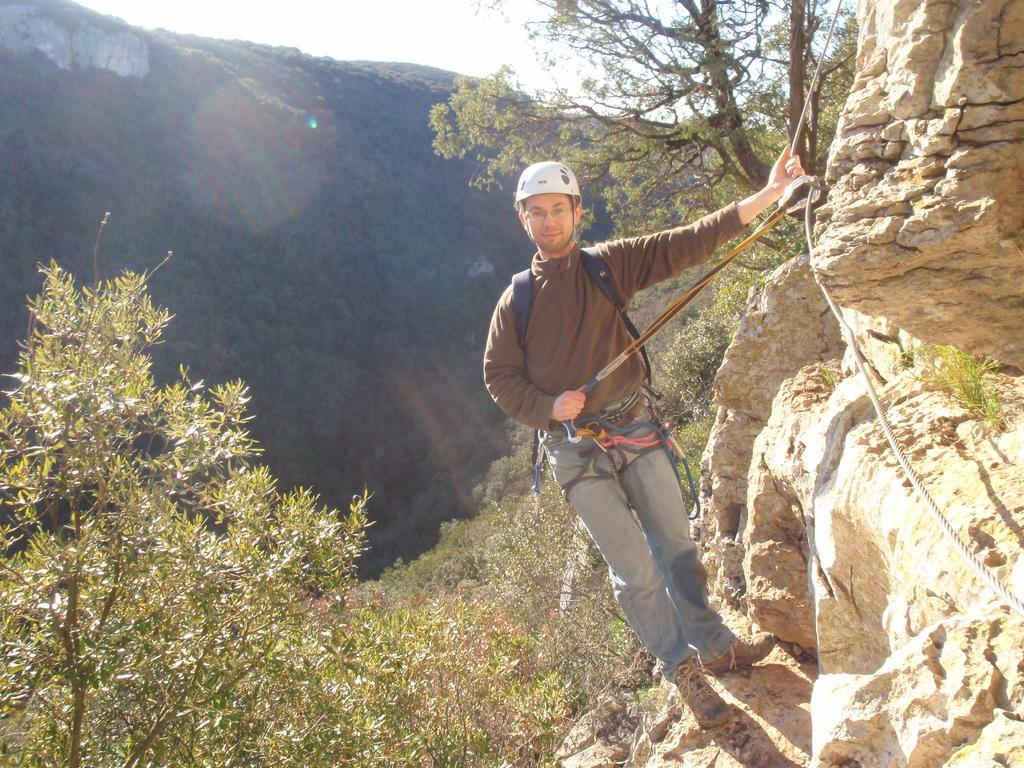Who is the person in the image? There is a man in the image. What is the man doing in the image? The man is climbing a mountain. What safety gear is the man wearing? The man is wearing a helmet. What equipment is the man using to climb the mountain? The man is using ropes. What can be seen on the right side of the image? There is a rock on the right side of the image. What is visible at the top of the image? The sky is visible at the top of the image. What type of drum can be heard playing in the background of the image? There is no drum or sound present in the image; it is a visual representation of a man climbing a mountain. 